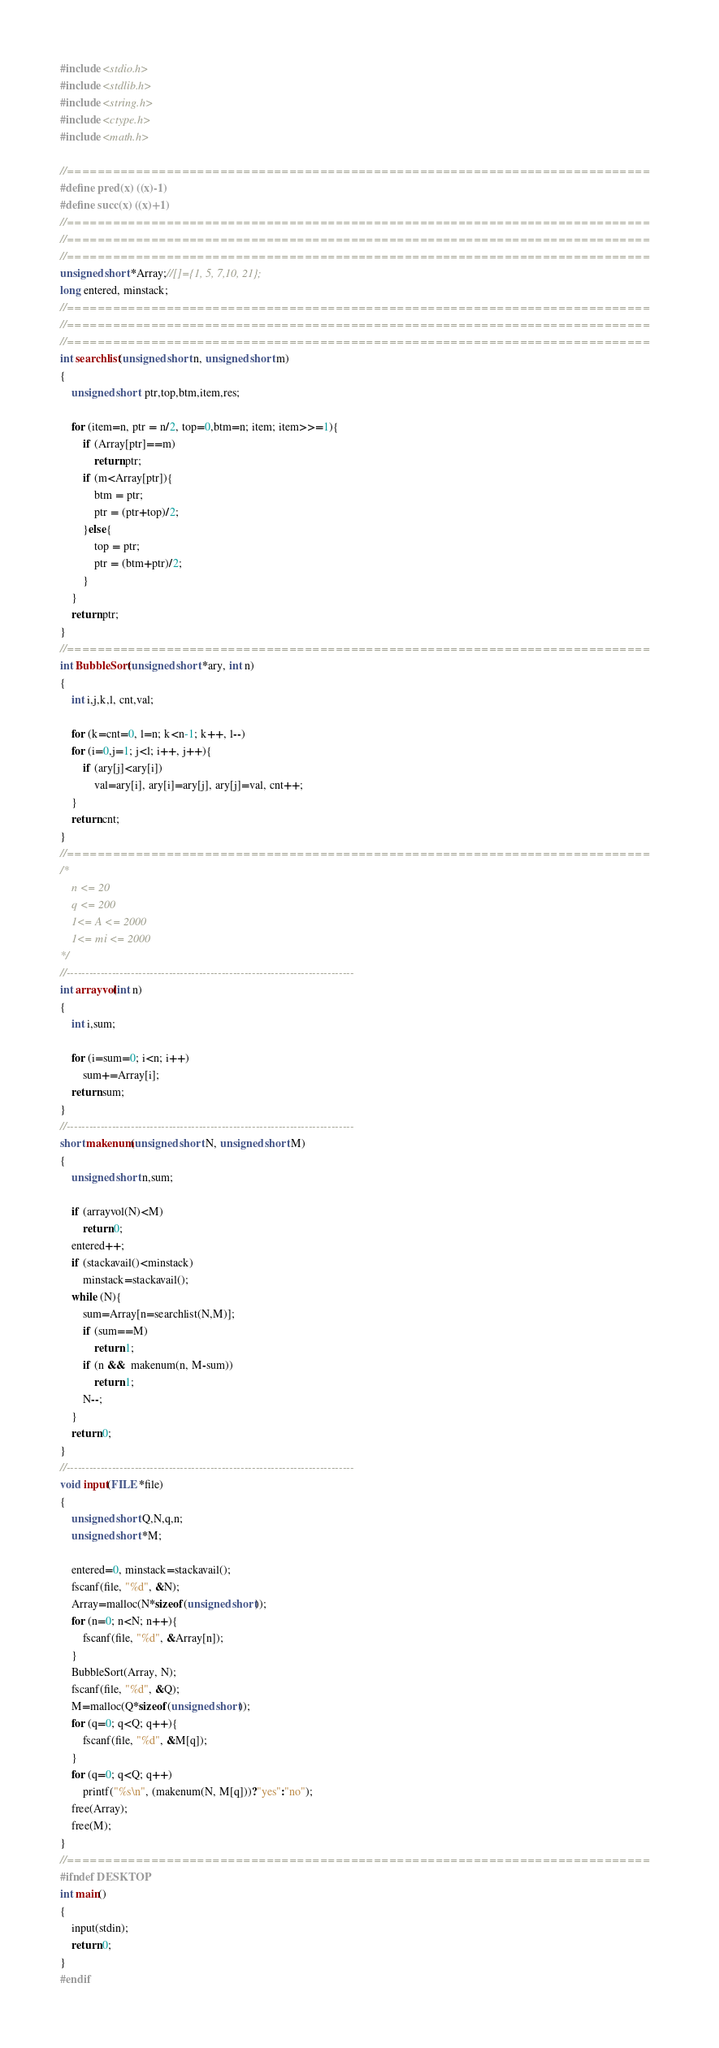<code> <loc_0><loc_0><loc_500><loc_500><_C_>#include <stdio.h>
#include <stdlib.h>
#include <string.h>
#include <ctype.h>
#include <math.h>

//============================================================================
#define pred(x) ((x)-1)
#define succ(x) ((x)+1)
//============================================================================
//============================================================================
//============================================================================
unsigned short *Array;//[]={1, 5, 7,10, 21};
long entered, minstack;
//============================================================================
//============================================================================
//============================================================================
int searchlist(unsigned short n, unsigned short m)
{
    unsigned short  ptr,top,btm,item,res;

    for (item=n, ptr = n/2, top=0,btm=n; item; item>>=1){
        if (Array[ptr]==m)
            return ptr;
        if (m<Array[ptr]){
            btm = ptr;
            ptr = (ptr+top)/2;
        }else{
            top = ptr;
            ptr = (btm+ptr)/2;
        }
    }
    return ptr;
}
//============================================================================
int BubbleSort(unsigned short *ary, int n)
{
    int i,j,k,l, cnt,val;

    for (k=cnt=0, l=n; k<n-1; k++, l--)
    for (i=0,j=1; j<l; i++, j++){
        if (ary[j]<ary[i])
            val=ary[i], ary[i]=ary[j], ary[j]=val, cnt++;
	}
    return cnt;
}
//============================================================================
/*
    n <= 20
    q <= 200
    1<= A <= 2000
    1<= mi <= 2000
*/
//----------------------------------------------------------------------------
int arrayvol(int n)
{
    int i,sum;

    for (i=sum=0; i<n; i++)
        sum+=Array[i];
    return sum;
}
//----------------------------------------------------------------------------
short makenum(unsigned short N, unsigned short M)
{
    unsigned short n,sum;

    if (arrayvol(N)<M)
        return 0;
    entered++;
    if (stackavail()<minstack)
        minstack=stackavail();
    while (N){
        sum=Array[n=searchlist(N,M)];
        if (sum==M)
            return 1;
        if (n &&  makenum(n, M-sum))
            return 1;
        N--;
    }
    return 0;
}
//----------------------------------------------------------------------------
void input(FILE *file)
{
    unsigned short Q,N,q,n;
    unsigned short *M;

    entered=0, minstack=stackavail();
    fscanf(file, "%d", &N);
    Array=malloc(N*sizeof(unsigned short));
    for (n=0; n<N; n++){
        fscanf(file, "%d", &Array[n]);
    }
    BubbleSort(Array, N);
    fscanf(file, "%d", &Q);
    M=malloc(Q*sizeof(unsigned short));
    for (q=0; q<Q; q++){
        fscanf(file, "%d", &M[q]);
    }
    for (q=0; q<Q; q++)
        printf("%s\n", (makenum(N, M[q]))?"yes":"no");
    free(Array);
    free(M);
}
//============================================================================
#ifndef DESKTOP
int main()
{
    input(stdin);
    return 0;
}
#endif</code> 